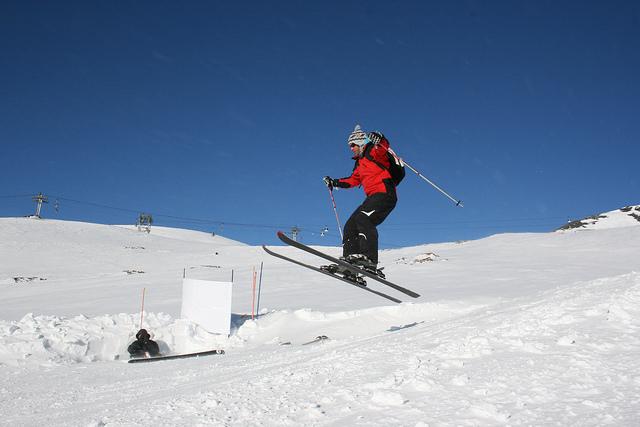Is the skier tired?
Answer briefly. No. What color is the man's jacket?
Short answer required. Red. Are there any clouds in the sky?
Write a very short answer. No. Are both of the man's skis on the snow?
Concise answer only. No. Is the man airborne?
Answer briefly. Yes. Is the man doing a trick?
Quick response, please. Yes. 